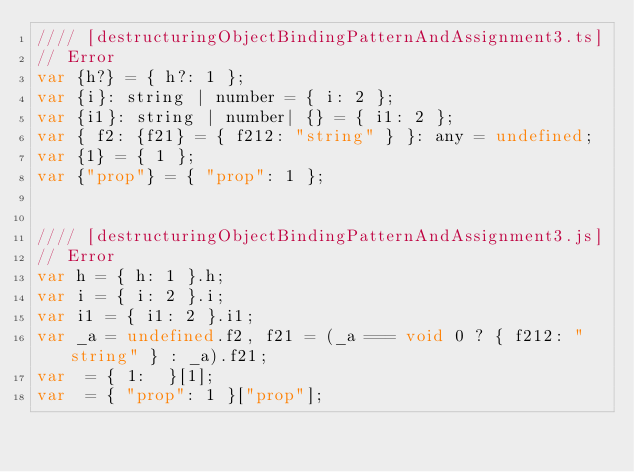Convert code to text. <code><loc_0><loc_0><loc_500><loc_500><_JavaScript_>//// [destructuringObjectBindingPatternAndAssignment3.ts]
// Error
var {h?} = { h?: 1 };
var {i}: string | number = { i: 2 };
var {i1}: string | number| {} = { i1: 2 };
var { f2: {f21} = { f212: "string" } }: any = undefined;
var {1} = { 1 };
var {"prop"} = { "prop": 1 };


//// [destructuringObjectBindingPatternAndAssignment3.js]
// Error
var h = { h: 1 }.h;
var i = { i: 2 }.i;
var i1 = { i1: 2 }.i1;
var _a = undefined.f2, f21 = (_a === void 0 ? { f212: "string" } : _a).f21;
var  = { 1:  }[1];
var  = { "prop": 1 }["prop"];
</code> 